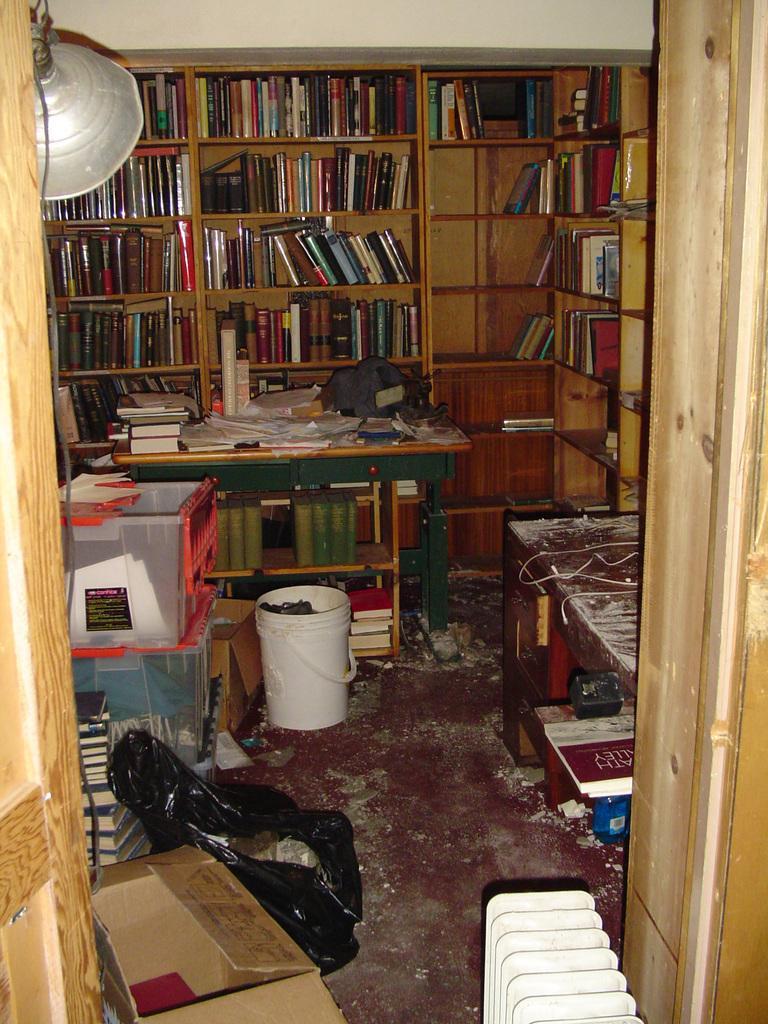Describe this image in one or two sentences. In this image i can see a book shelf and books in it, a table, a bucket and a cover. 